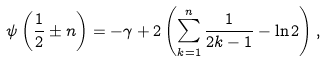<formula> <loc_0><loc_0><loc_500><loc_500>\psi \left ( \frac { 1 } { 2 } \pm n \right ) = - \gamma + 2 \left ( \sum _ { k = 1 } ^ { n } \frac { 1 } { 2 k - 1 } - \ln 2 \right ) ,</formula> 